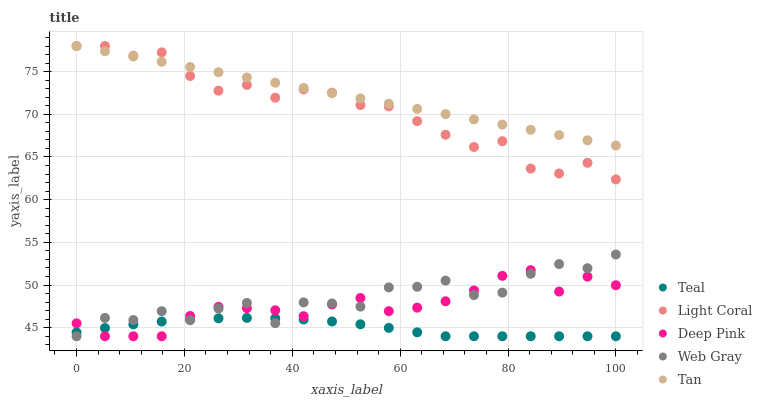Does Teal have the minimum area under the curve?
Answer yes or no. Yes. Does Tan have the maximum area under the curve?
Answer yes or no. Yes. Does Deep Pink have the minimum area under the curve?
Answer yes or no. No. Does Deep Pink have the maximum area under the curve?
Answer yes or no. No. Is Tan the smoothest?
Answer yes or no. Yes. Is Web Gray the roughest?
Answer yes or no. Yes. Is Deep Pink the smoothest?
Answer yes or no. No. Is Deep Pink the roughest?
Answer yes or no. No. Does Deep Pink have the lowest value?
Answer yes or no. Yes. Does Tan have the lowest value?
Answer yes or no. No. Does Tan have the highest value?
Answer yes or no. Yes. Does Deep Pink have the highest value?
Answer yes or no. No. Is Deep Pink less than Tan?
Answer yes or no. Yes. Is Tan greater than Web Gray?
Answer yes or no. Yes. Does Deep Pink intersect Teal?
Answer yes or no. Yes. Is Deep Pink less than Teal?
Answer yes or no. No. Is Deep Pink greater than Teal?
Answer yes or no. No. Does Deep Pink intersect Tan?
Answer yes or no. No. 